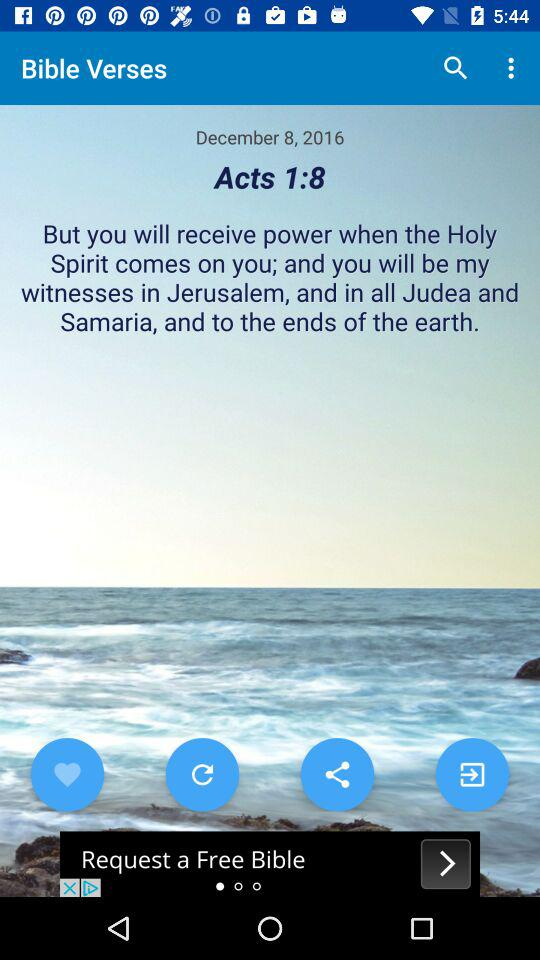What is the title of the "Bible" verse? The title is "Acts 1:8". 